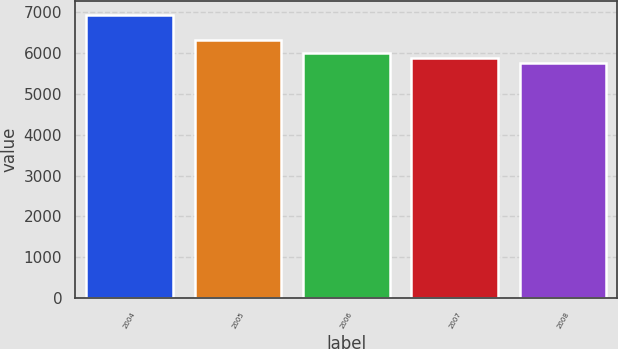Convert chart. <chart><loc_0><loc_0><loc_500><loc_500><bar_chart><fcel>2004<fcel>2005<fcel>2006<fcel>2007<fcel>2008<nl><fcel>6935<fcel>6314<fcel>6009<fcel>5891<fcel>5755<nl></chart> 